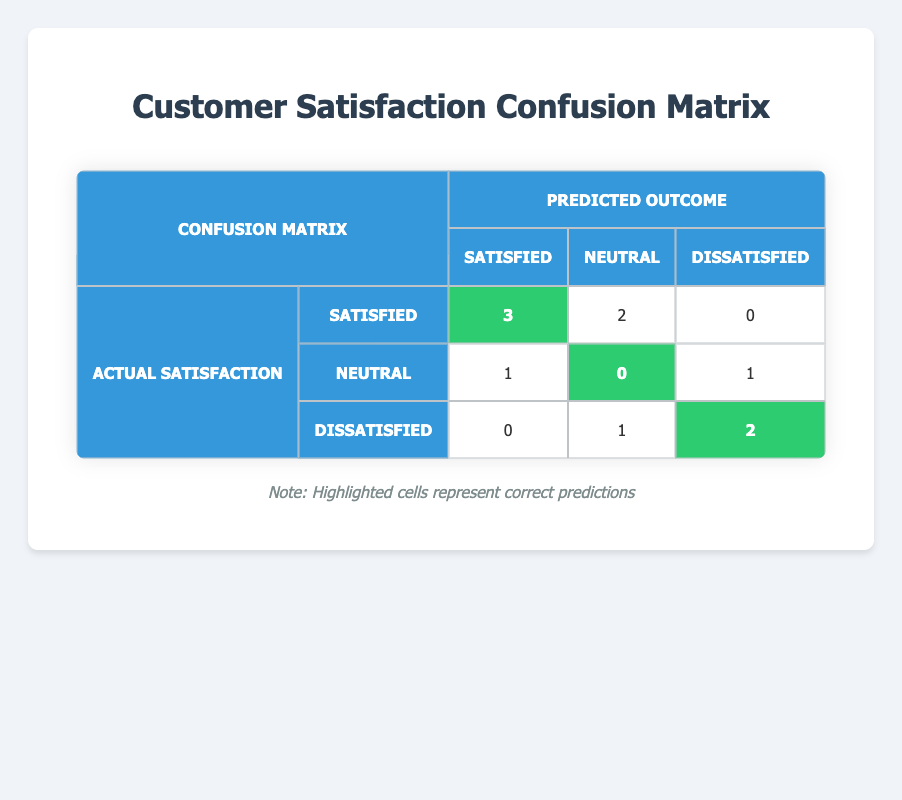What are the total actual "Satisfied" ratings that were predicted as "Satisfied"? In the confusion matrix, we look at the row for "Satisfied" and the column for "Satisfied." The value is 3, which indicates that 3 customers who were actually satisfied were also predicted to be satisfied.
Answer: 3 How many customers were actually "Dissatisfied" and predicted to be "Dissatisfied"? We check the row for "Dissatisfied" and the column for "Dissatisfied." The value in that cell is 2, so 2 customers who were actually dissatisfied were correctly predicted as dissatisfied.
Answer: 2 Is there a customer who was "Neutral" that was predicted to be "Satisfied"? We refer to the row for "Neutral" and the column for "Satisfied." The value in that cell is 0, which means no neutral customers were incorrectly predicted as satisfied.
Answer: No What is the total number of correct predictions in the matrix? To find the correct predictions, we sum up the highlighted values in the matrix: 3 (Satisfied-Satisfied) + 2 (Dissatisfied-Dissatisfied) + 0 (Neutral-Neutral) = 5 correct predictions.
Answer: 5 How many customers were correctly predicted as "Neutral"? We find the number of correct predictions for "Neutral" outcomes in the confusion matrix. According to the row for "Neutral," the highlighted cell indicates that 0 neutral customers were correctly predicted as neutral.
Answer: 0 What is the total number of predictions made for "Satisfied"? To find the total predictions for "Satisfied," we sum up all values in the "Satisfied" row: 3 (true positives) + 2 (false negatives) + 0 (false positives) = 5 total predictions for "Satisfied."
Answer: 5 If a customer was predicted as "Neutral," what is the probability that they were actually "Dissatisfied"? In the confusion matrix, we see that 1 customer was predicted as "Neutral" and was actually "Dissatisfied." The total number of predicted neutrals is the sum of the "Neutral" column: 2 (Neutral to Neutral) + 1 (Neutral to Dissatisfied) + 3 (Satisfied to Neutral) = 6. Therefore, the probability is 1 out of 6, which simplifies to approximately 0.167 or 16.7%.
Answer: 16.7% What is the difference between the number of customers who were predicted as "Satisfied" and the number who were actually "Satisfied"? We look at the total predicted as "Satisfied," which is the sum of the "Satisfied" column: 3 (from Satisfied) + 1 (from Neutral) + 0 (from Dissatisfied) = 4. The actual "Satisfied" is also 5. Therefore, the difference is 4 - 5 = -1, indicating an underestimation.
Answer: -1 